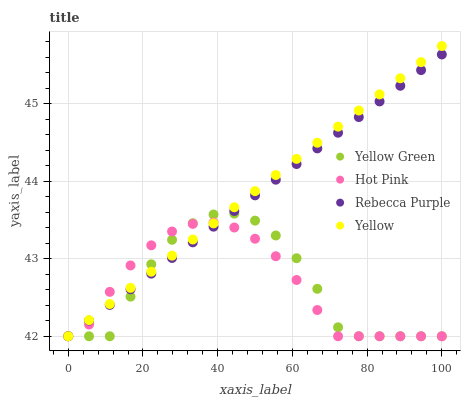Does Yellow Green have the minimum area under the curve?
Answer yes or no. Yes. Does Yellow have the maximum area under the curve?
Answer yes or no. Yes. Does Yellow have the minimum area under the curve?
Answer yes or no. No. Does Yellow Green have the maximum area under the curve?
Answer yes or no. No. Is Yellow the smoothest?
Answer yes or no. Yes. Is Yellow Green the roughest?
Answer yes or no. Yes. Is Yellow Green the smoothest?
Answer yes or no. No. Is Yellow the roughest?
Answer yes or no. No. Does Hot Pink have the lowest value?
Answer yes or no. Yes. Does Yellow have the highest value?
Answer yes or no. Yes. Does Yellow Green have the highest value?
Answer yes or no. No. Does Hot Pink intersect Yellow?
Answer yes or no. Yes. Is Hot Pink less than Yellow?
Answer yes or no. No. Is Hot Pink greater than Yellow?
Answer yes or no. No. 